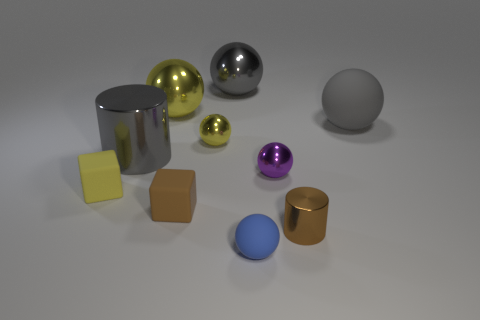Subtract 3 balls. How many balls are left? 3 Subtract all purple spheres. How many spheres are left? 5 Subtract all big gray spheres. How many spheres are left? 4 Subtract all cyan balls. Subtract all blue blocks. How many balls are left? 6 Subtract all cubes. How many objects are left? 8 Subtract 0 purple cylinders. How many objects are left? 10 Subtract all metallic cylinders. Subtract all yellow matte cubes. How many objects are left? 7 Add 8 brown blocks. How many brown blocks are left? 9 Add 3 blue spheres. How many blue spheres exist? 4 